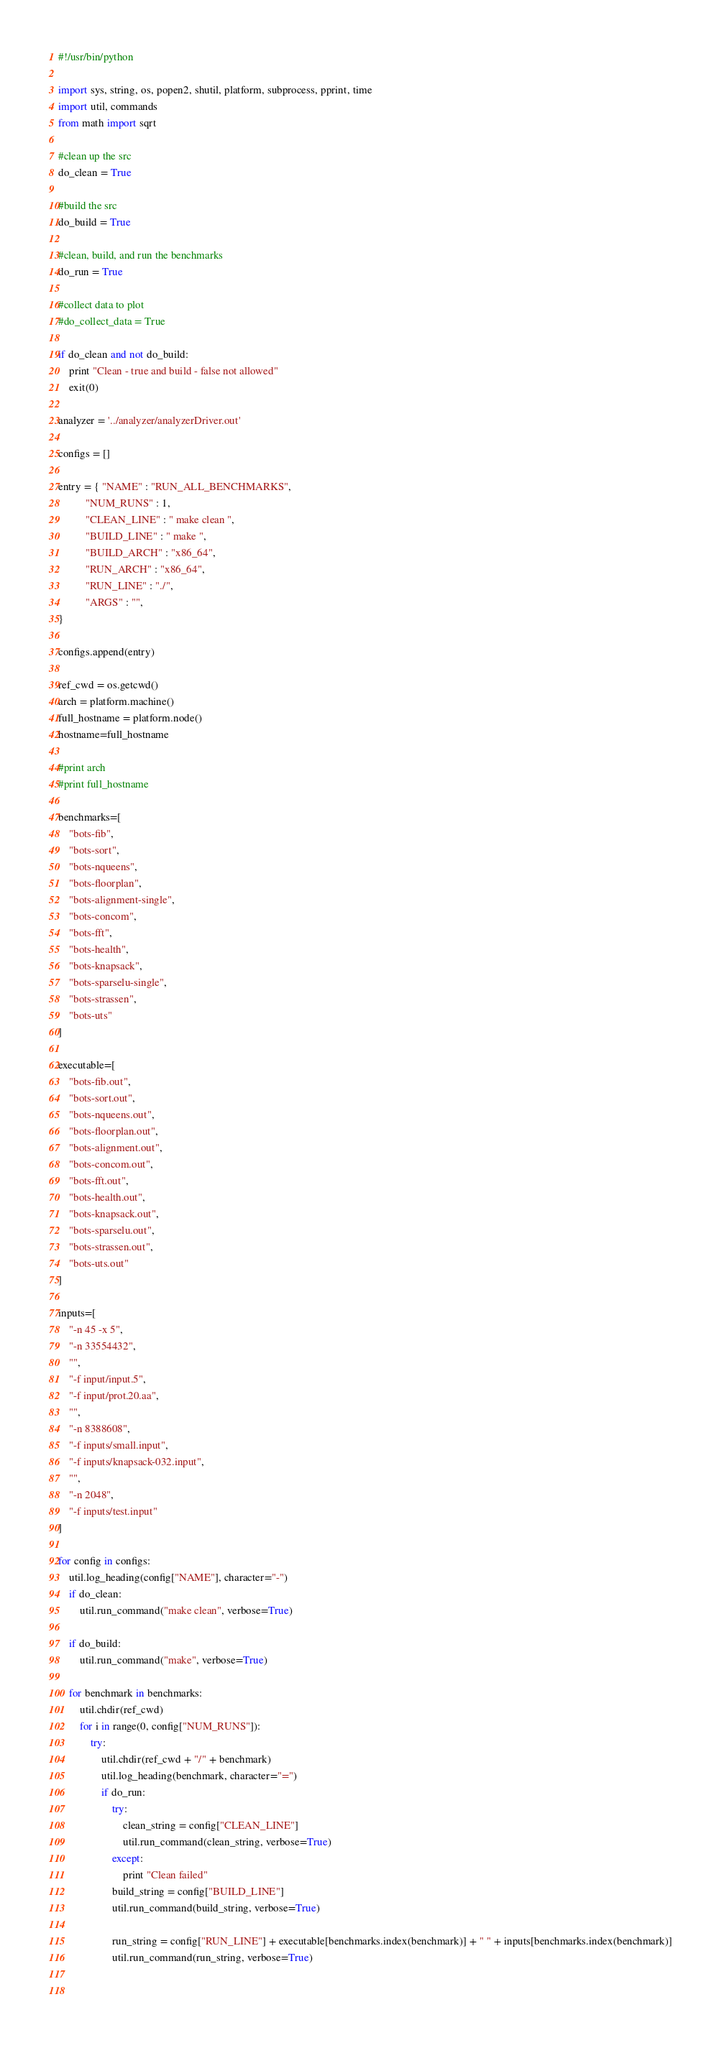<code> <loc_0><loc_0><loc_500><loc_500><_Python_>#!/usr/bin/python

import sys, string, os, popen2, shutil, platform, subprocess, pprint, time
import util, commands
from math import sqrt

#clean up the src 
do_clean = True

#build the src
do_build = True

#clean, build, and run the benchmarks
do_run = True

#collect data to plot
#do_collect_data = True

if do_clean and not do_build:
    print "Clean - true and build - false not allowed"
    exit(0)

analyzer = '../analyzer/analyzerDriver.out'

configs = []

entry = { "NAME" : "RUN_ALL_BENCHMARKS",
          "NUM_RUNS" : 1,
          "CLEAN_LINE" : " make clean ",
          "BUILD_LINE" : " make ",
          "BUILD_ARCH" : "x86_64",
          "RUN_ARCH" : "x86_64",
          "RUN_LINE" : "./",
          "ARGS" : "",
}

configs.append(entry)

ref_cwd = os.getcwd()
arch = platform.machine()
full_hostname = platform.node()
hostname=full_hostname

#print arch
#print full_hostname

benchmarks=[
    "bots-fib",
    "bots-sort",
    "bots-nqueens",
    "bots-floorplan",
    "bots-alignment-single",
    "bots-concom",
    "bots-fft",
    "bots-health",
    "bots-knapsack",
    "bots-sparselu-single",
    "bots-strassen",
    "bots-uts"
]

executable=[
    "bots-fib.out",
    "bots-sort.out",
    "bots-nqueens.out",
    "bots-floorplan.out",
    "bots-alignment.out",
    "bots-concom.out",
    "bots-fft.out",
    "bots-health.out",
    "bots-knapsack.out",
    "bots-sparselu.out",
    "bots-strassen.out",
    "bots-uts.out"
]

inputs=[
    "-n 45 -x 5",
    "-n 33554432",
    "",
    "-f input/input.5",
    "-f input/prot.20.aa",
    "",
    "-n 8388608",
    "-f inputs/small.input",
    "-f inputs/knapsack-032.input",
    "",
    "-n 2048",
    "-f inputs/test.input"
]

for config in configs:
    util.log_heading(config["NAME"], character="-")
    if do_clean:
        util.run_command("make clean", verbose=True)
        
    if do_build:
        util.run_command("make", verbose=True)
        
    for benchmark in benchmarks:
        util.chdir(ref_cwd)
        for i in range(0, config["NUM_RUNS"]):
            try:
                util.chdir(ref_cwd + "/" + benchmark)
                util.log_heading(benchmark, character="=")
                if do_run:
                    try:
                        clean_string = config["CLEAN_LINE"]
                        util.run_command(clean_string, verbose=True)
                    except:
                        print "Clean failed"
                    build_string = config["BUILD_LINE"]
                    util.run_command(build_string, verbose=True)

                    run_string = config["RUN_LINE"] + executable[benchmarks.index(benchmark)] + " " + inputs[benchmarks.index(benchmark)]
                    util.run_command(run_string, verbose=True)

                    </code> 